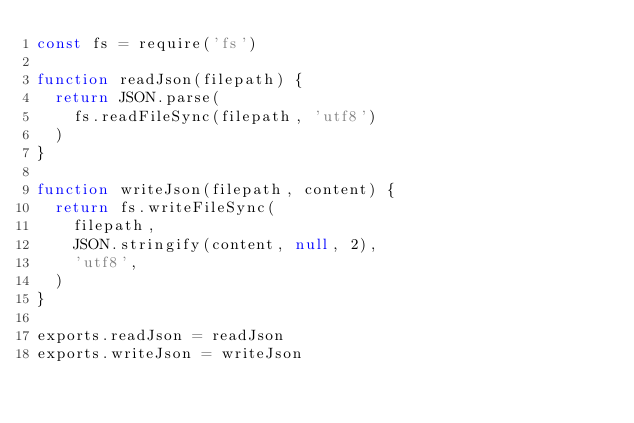<code> <loc_0><loc_0><loc_500><loc_500><_JavaScript_>const fs = require('fs')

function readJson(filepath) {
  return JSON.parse(
    fs.readFileSync(filepath, 'utf8')
  )
}

function writeJson(filepath, content) {
  return fs.writeFileSync(
    filepath,
    JSON.stringify(content, null, 2),
    'utf8',
  )
}

exports.readJson = readJson
exports.writeJson = writeJson
</code> 